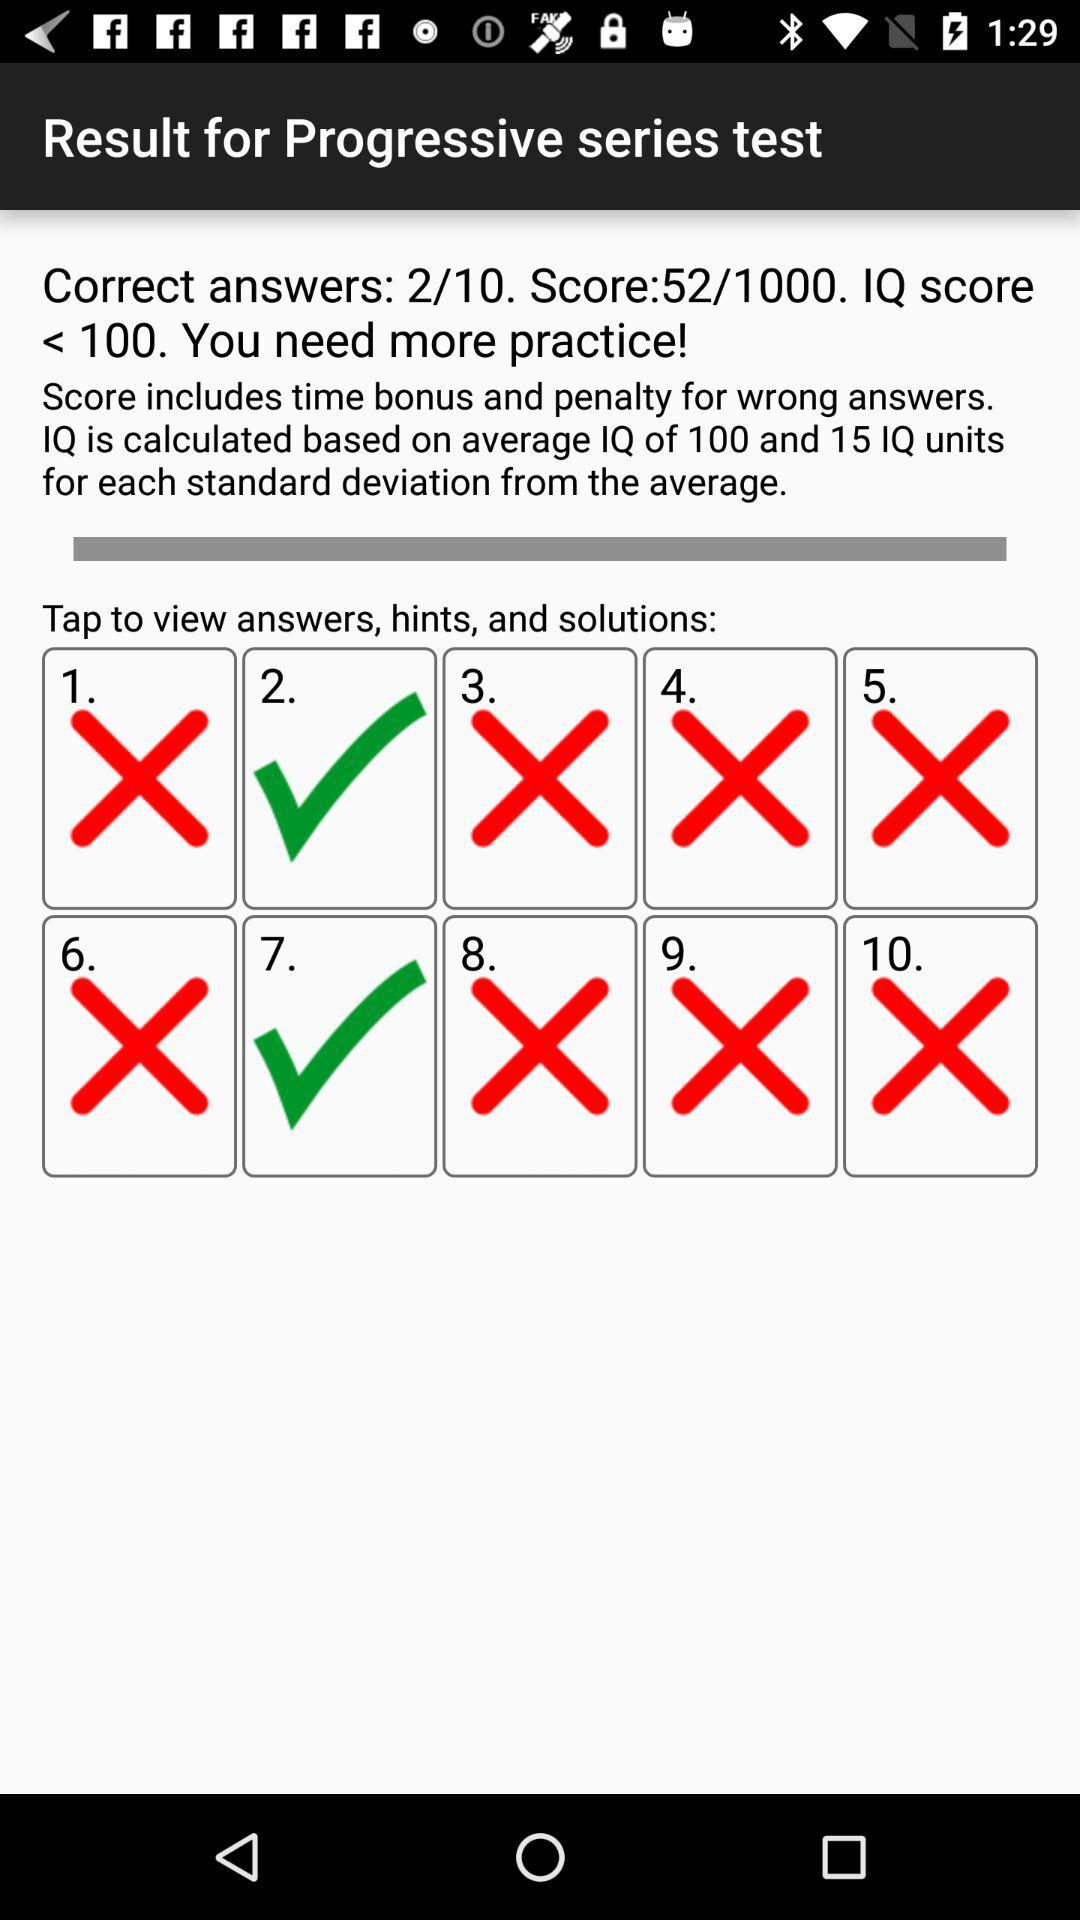What is the score? The score is 52 out of 1000. 